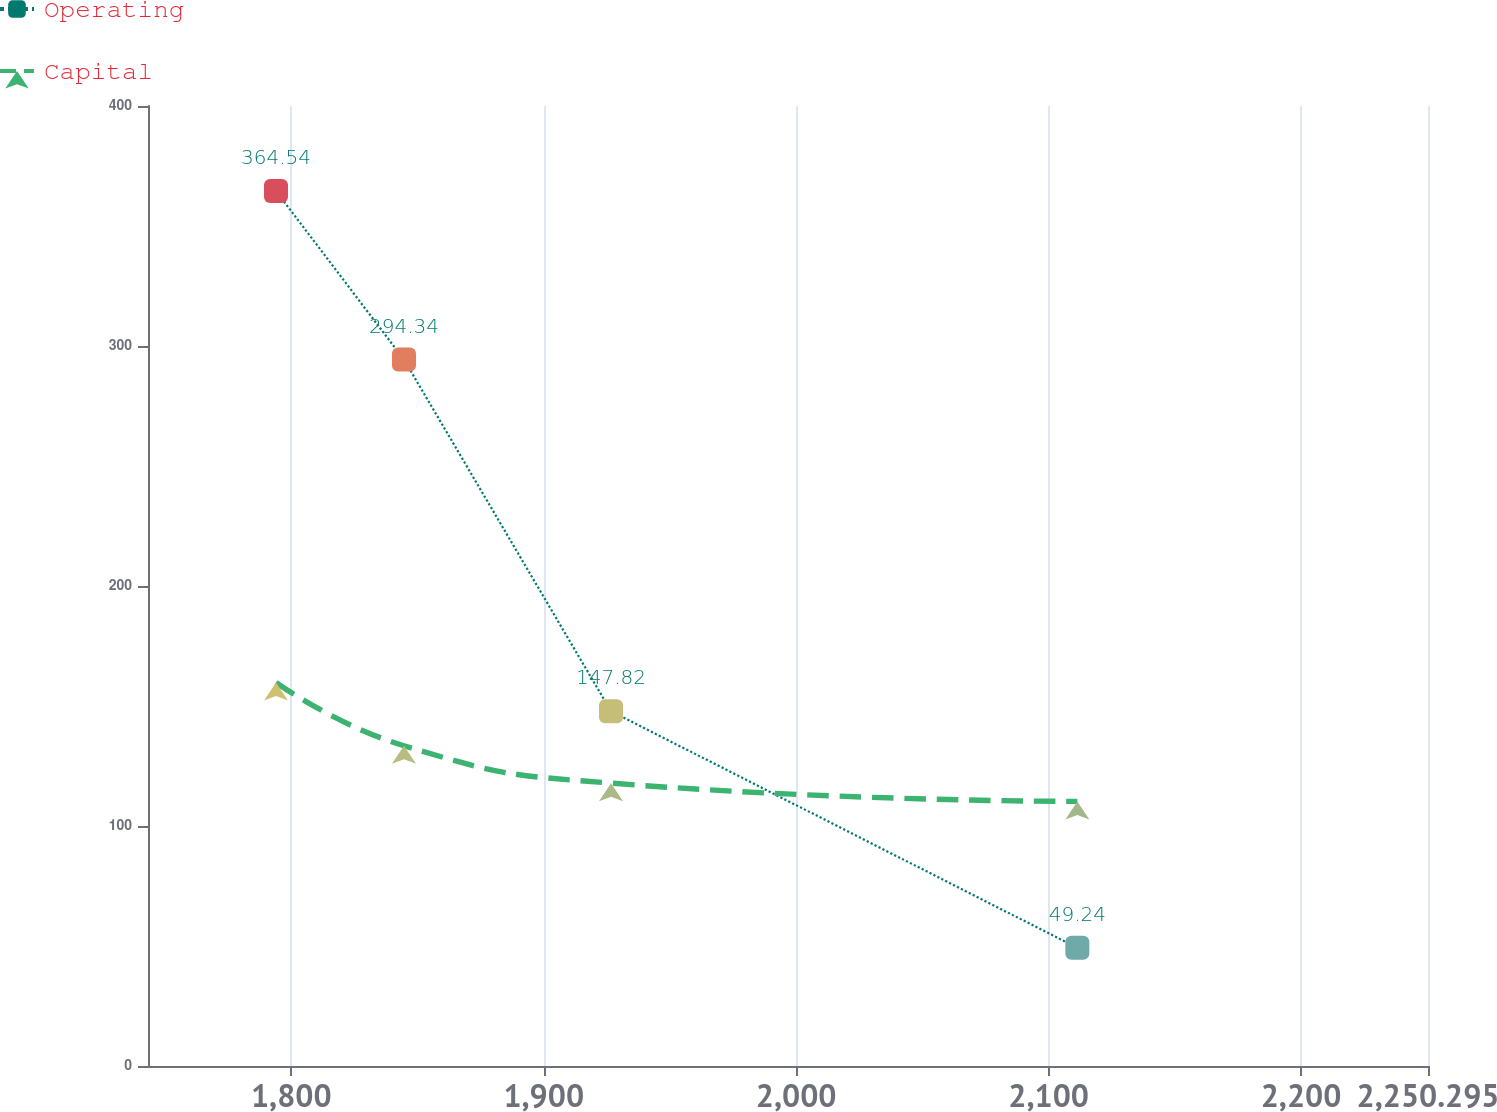Convert chart. <chart><loc_0><loc_0><loc_500><loc_500><line_chart><ecel><fcel>Operating<fcel>Capital<nl><fcel>1793.95<fcel>364.54<fcel>159.8<nl><fcel>1844.65<fcel>294.34<fcel>133.43<nl><fcel>1926.66<fcel>147.82<fcel>117.86<nl><fcel>2111.39<fcel>49.24<fcel>110.25<nl><fcel>2301<fcel>14.21<fcel>83.74<nl></chart> 